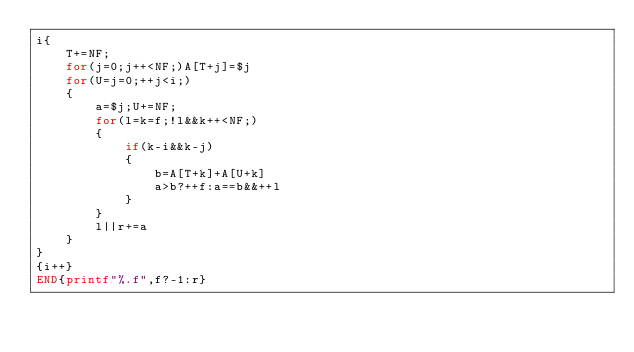<code> <loc_0><loc_0><loc_500><loc_500><_Awk_>i{
	T+=NF;
	for(j=0;j++<NF;)A[T+j]=$j
	for(U=j=0;++j<i;)
	{
		a=$j;U+=NF;
		for(l=k=f;!l&&k++<NF;)
		{
			if(k-i&&k-j)
			{
				b=A[T+k]+A[U+k]
				a>b?++f:a==b&&++l
			}
		}
		l||r+=a
	}
}
{i++}
END{printf"%.f",f?-1:r}</code> 